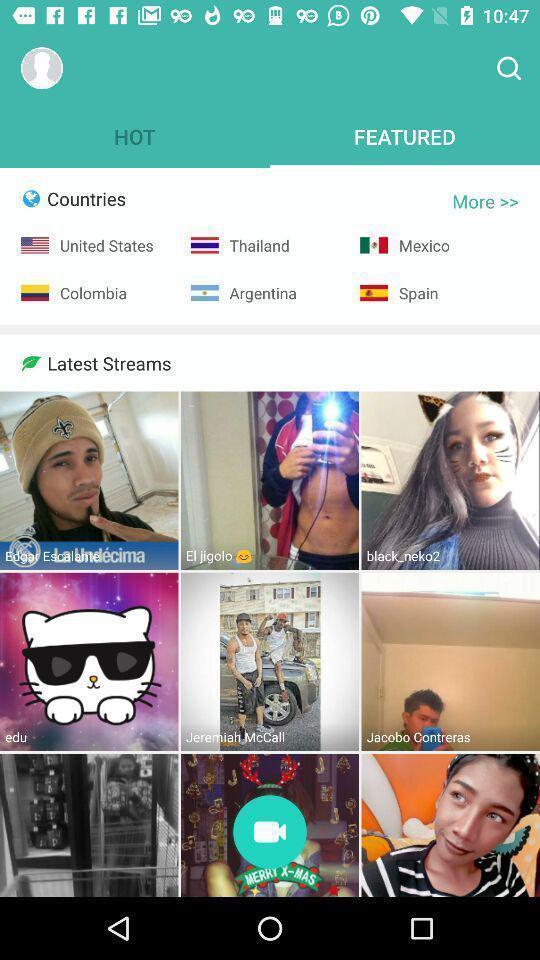Provide a description of this screenshot. Page showing featured on a live streaming app. 